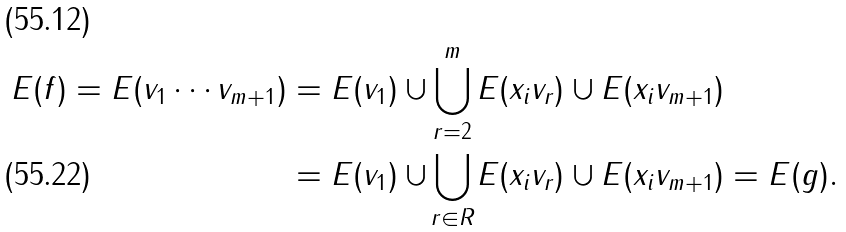Convert formula to latex. <formula><loc_0><loc_0><loc_500><loc_500>E ( f ) = E ( v _ { 1 } \cdots v _ { m + 1 } ) & = E ( v _ { 1 } ) \cup \bigcup _ { \mathclap { r = 2 } } ^ { m } E ( x _ { i } v _ { r } ) \cup E ( x _ { i } v _ { m + 1 } ) \\ & = E ( v _ { 1 } ) \cup \bigcup _ { \mathclap { r \in R } } E ( x _ { i } v _ { r } ) \cup E ( x _ { i } v _ { m + 1 } ) = E ( g ) .</formula> 